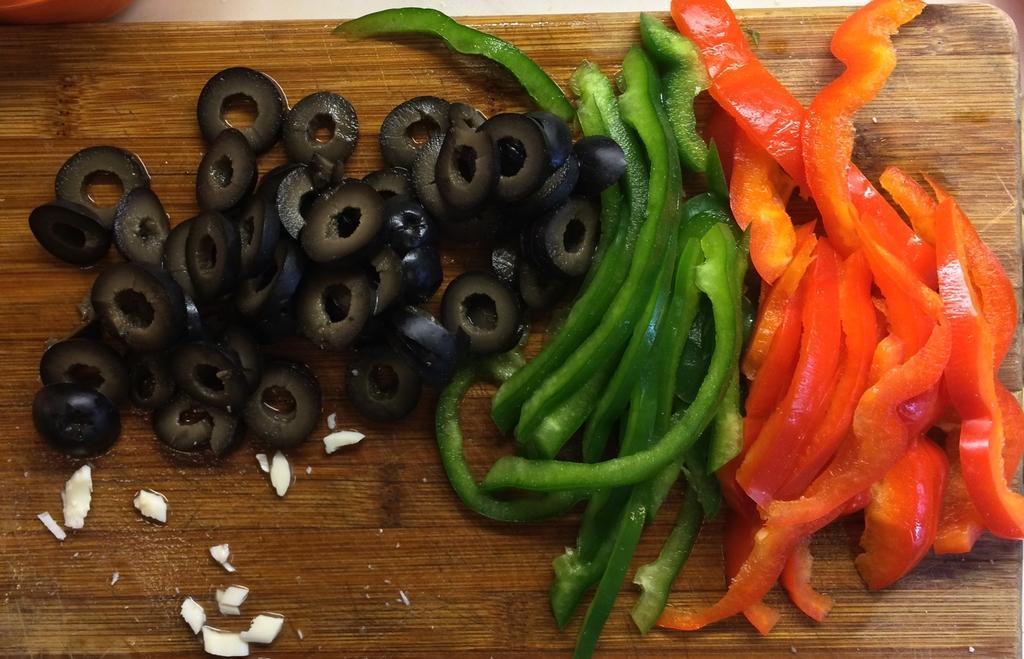How would you summarize this image in a sentence or two? In this image at the bottom there is a cutting board, on the board there are some olives and capsicums. 